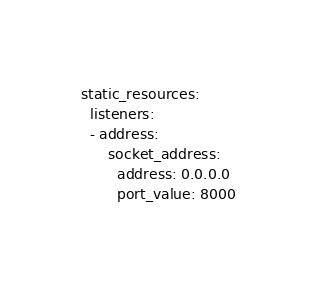<code> <loc_0><loc_0><loc_500><loc_500><_YAML_>static_resources:
  listeners:
  - address:
      socket_address:
        address: 0.0.0.0
        port_value: 8000</code> 